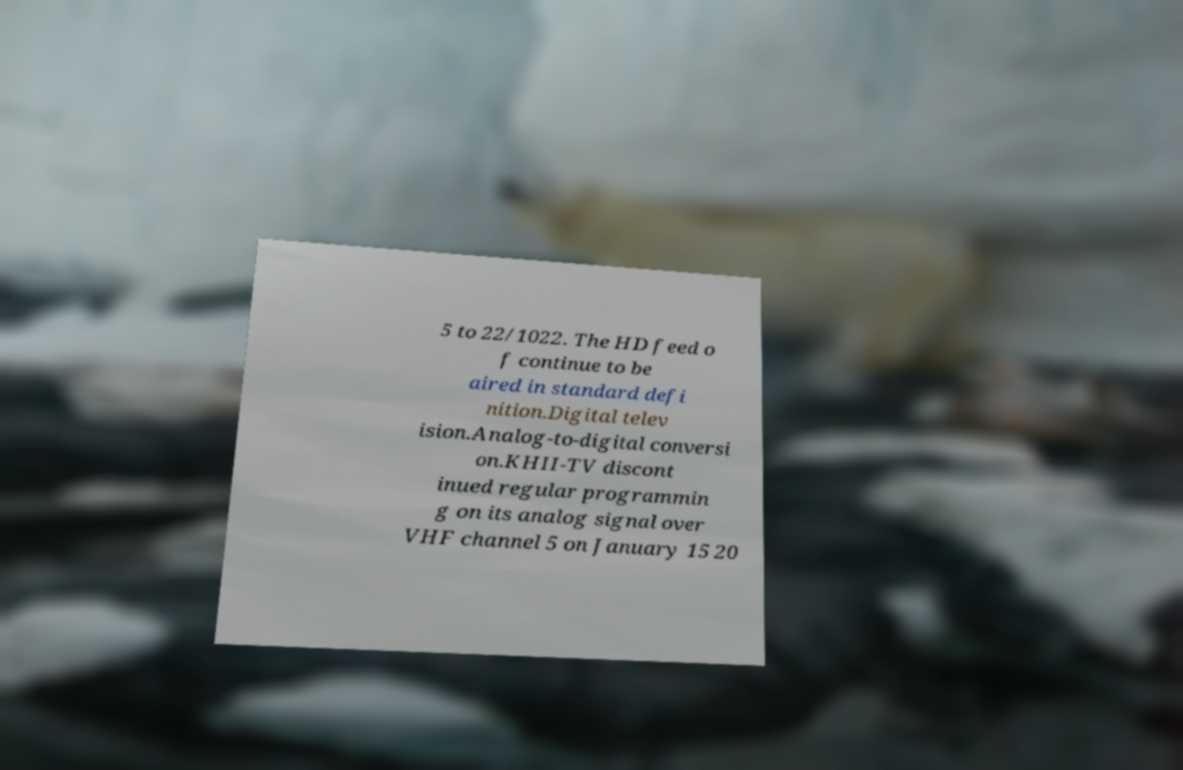Can you accurately transcribe the text from the provided image for me? 5 to 22/1022. The HD feed o f continue to be aired in standard defi nition.Digital telev ision.Analog-to-digital conversi on.KHII-TV discont inued regular programmin g on its analog signal over VHF channel 5 on January 15 20 